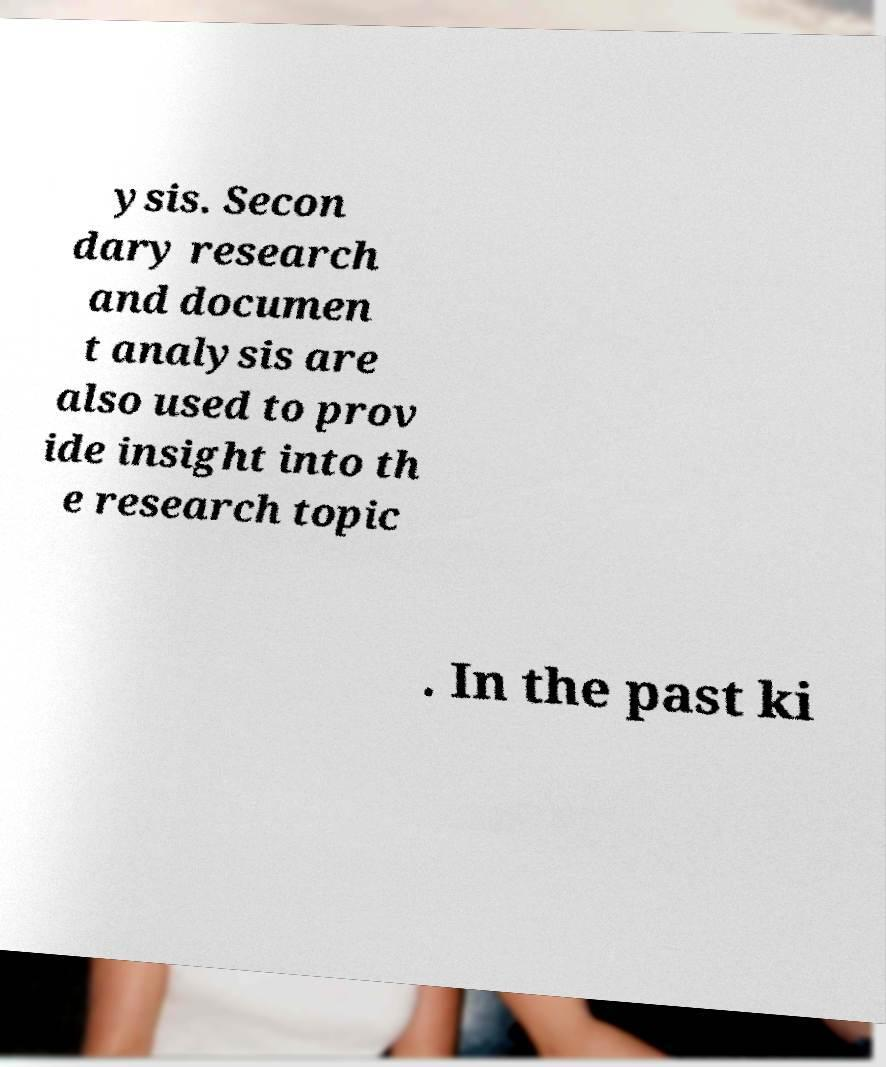Please identify and transcribe the text found in this image. ysis. Secon dary research and documen t analysis are also used to prov ide insight into th e research topic . In the past ki 